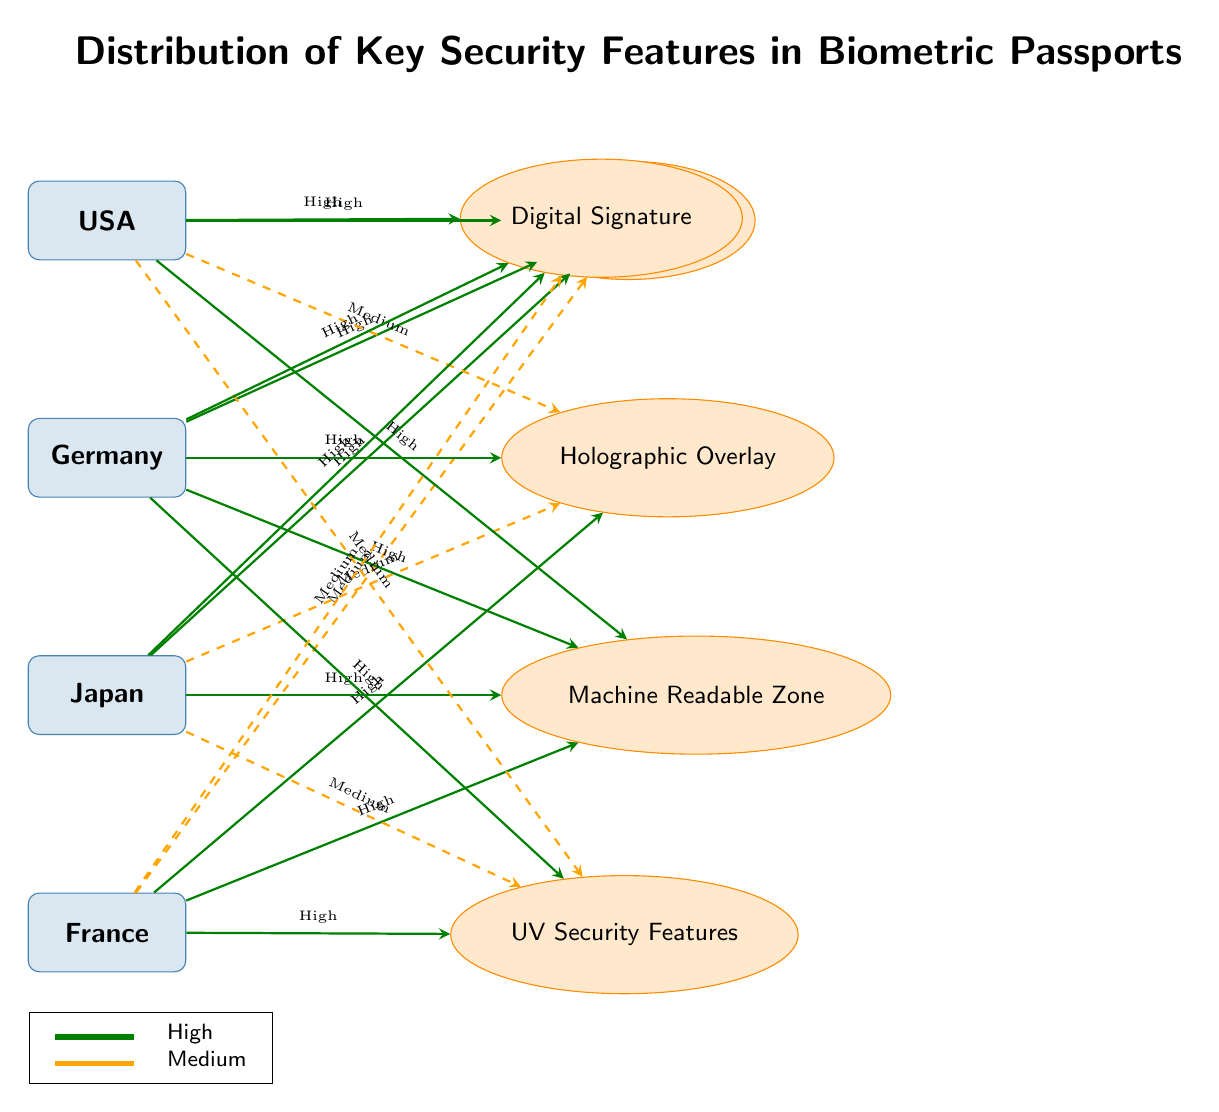What country has the highest number of high-rated security features? The diagram shows that Germany has high ratings for multiple features, particularly in Holographic Overlay, Machine Readable Zone, and Digital Signature. Thus, it has the highest number of high-rated security features compared to the others.
Answer: Germany Which country has a medium rating for UV Security Features? The connections to UV Security Features reveal that both the USA and Japan have a medium rating, as indicated by the dashed arrows pointing from these countries to the feature.
Answer: USA, Japan What is the rating level of France for the Biometric Chip feature? According to the diagram, France has a medium rating for the Biometric Chip feature, indicated by a dashed arrow leading from France to Biometric Chip.
Answer: Medium How many features have a high rating for Japan? The diagram indicates that Japan has high ratings for three features: Biometric Chip, Machine Readable Zone, and Digital Signature. Thus, the count is three high-rated features.
Answer: 3 Which feature is not rated high by France? Upon reviewing the diagram connections, it shows that France has a medium rating for the Biometric Chip, and a medium rating for the Digital Signature as well. Therefore, the feature that is not rated high by France is the Digital Signature.
Answer: Digital Signature Which country's passport features a medium rating for Holographic Overlay? The connections on the diagram show that Japan has a medium rating for Holographic Overlay, as indicated by the dashed arrow connecting Japan to this feature.
Answer: Japan What is the relationship between the USA and the Digital Signature feature? The diagram visualizes a strong connection from the USA to the Digital Signature feature, with a solid arrow indicating a high rating level, thus establishing a direct relationship.
Answer: High In total, how many features are shown in the diagram? Counting the features in the diagram, there are five in total: Biometric Chip, Holographic Overlay, Machine Readable Zone, UV Security Features, and Digital Signature.
Answer: 5 